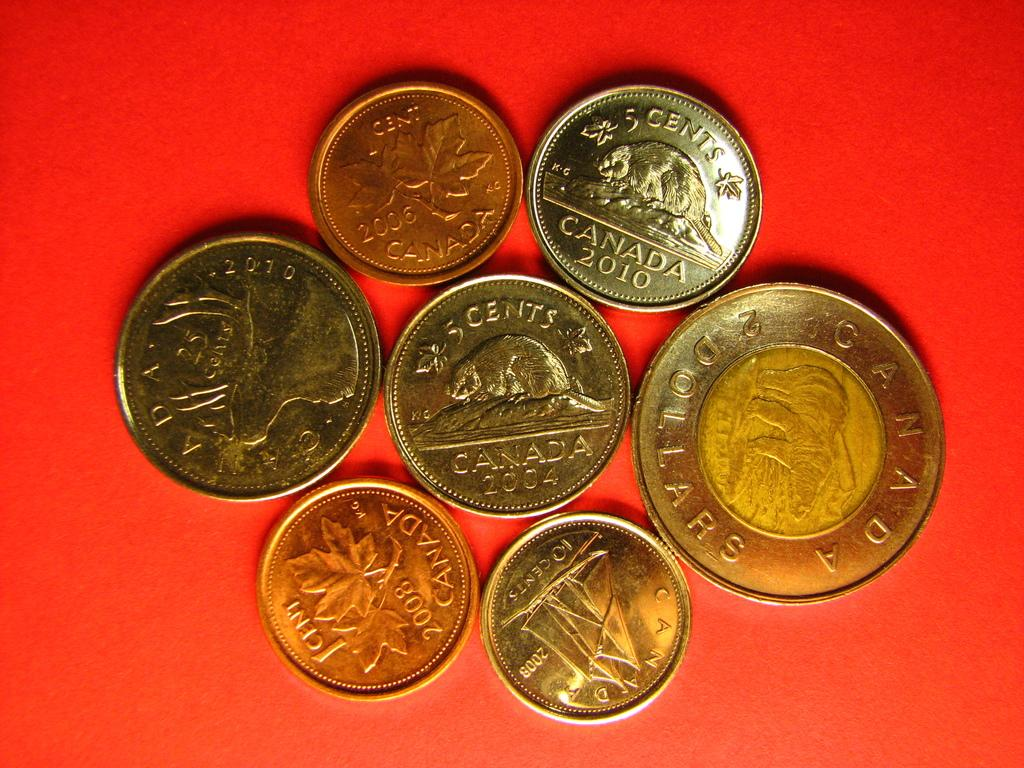<image>
Share a concise interpretation of the image provided. several canadian coins are laying on a red background 